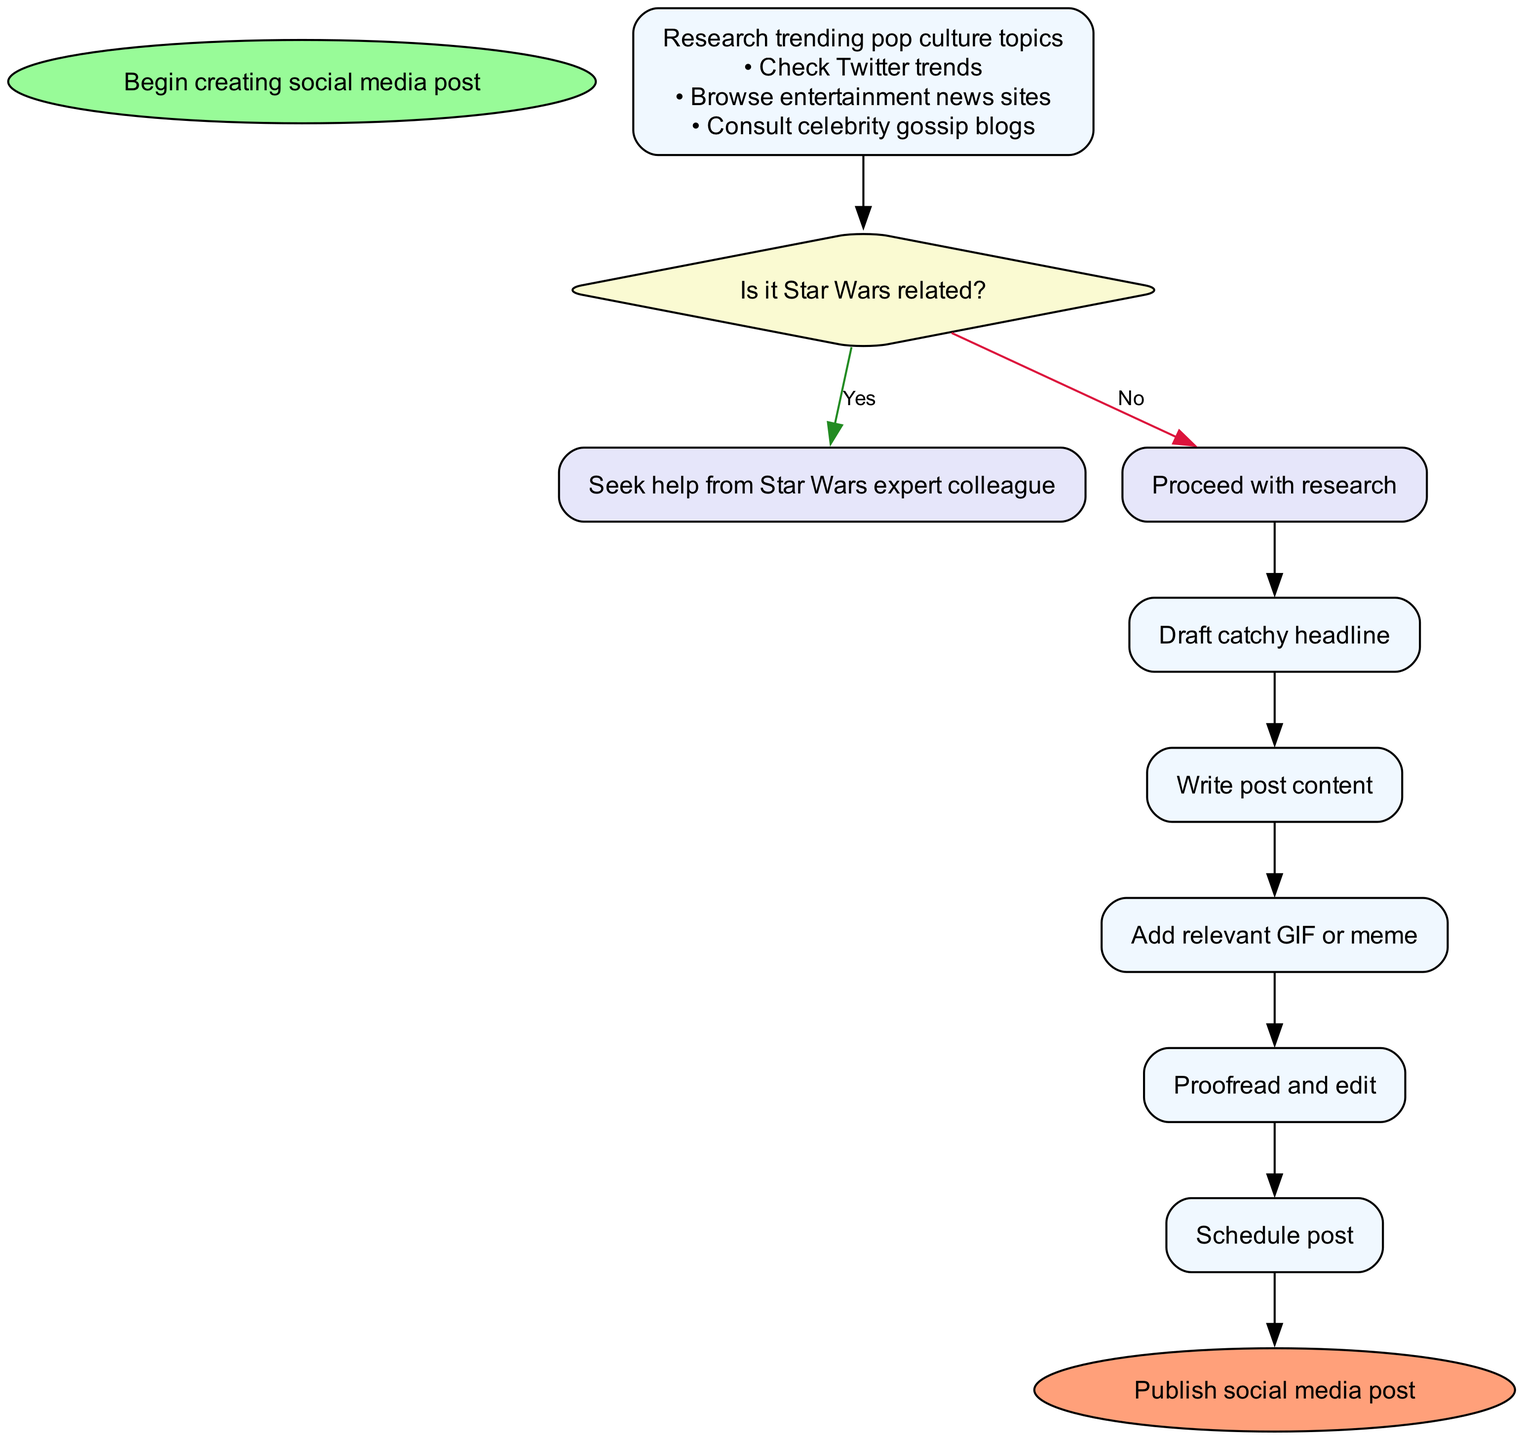What is the first action in the flowchart? The flowchart begins with the "Begin creating social media post" action, which is the starting point of the process.
Answer: Begin creating social media post How many steps are outlined in the flowchart? The diagram outlines a total of 7 steps in creating a social media post, excluding the start and end nodes.
Answer: 7 What is the last action before publishing the post? The final action before publishing the post is "Proofread and edit," ensuring that all details of the post are checked for accuracy.
Answer: Proofread and edit Which node involves a conditional action? The node that involves a conditional action is "Select topic," where the decision is made based on whether the topic is Star Wars related or not.
Answer: Select topic What is the next step after "Draft catchy headline"? After "Draft catchy headline," the next step is "Write post content," where the actual content of the social media post is created.
Answer: Write post content What is the main focus when writing the post content? The main focus when writing the post content is to emphasize personal amazement at the pop culture phenomenon being discussed.
Answer: Emphasize personal amazement at pop culture phenomenon In the "Select topic" step, what do you do if the topic is Star Wars related? If the topic is Star Wars related, you are instructed to "Seek help from Star Wars expert colleague" to enhance the post's content.
Answer: Seek help from Star Wars expert colleague What sources are recommended for adding a relevant GIF or meme? The recommended sources for adding a relevant GIF or meme are "GIPHY or Imgflip," which are known for their extensive collections of media.
Answer: GIPHY or Imgflip What should be ensured during the proofreading and editing stage? During the proofreading and editing stage, it must be ensured that all pop culture references included in the post are accurate to maintain credibility.
Answer: Ensure pop culture references are accurate 